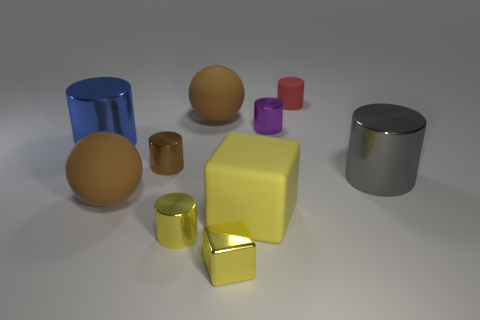Subtract 1 cylinders. How many cylinders are left? 5 Subtract all purple cylinders. How many cylinders are left? 5 Subtract all big gray cylinders. How many cylinders are left? 5 Subtract all red cylinders. Subtract all gray spheres. How many cylinders are left? 5 Subtract all spheres. How many objects are left? 8 Add 6 brown balls. How many brown balls exist? 8 Subtract 2 brown spheres. How many objects are left? 8 Subtract all cubes. Subtract all red matte cubes. How many objects are left? 8 Add 7 yellow things. How many yellow things are left? 10 